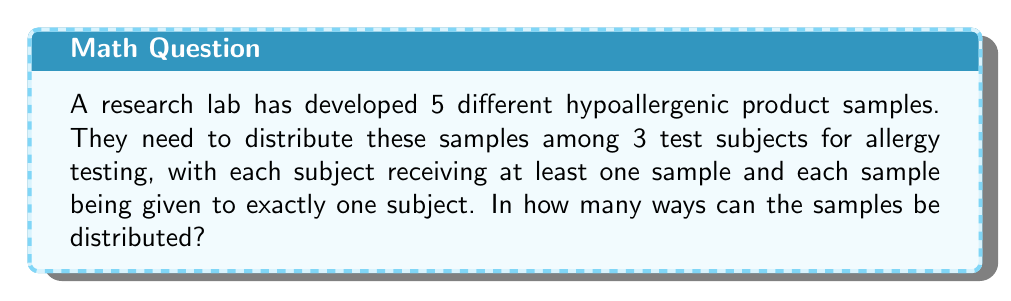Provide a solution to this math problem. Let's approach this step-by-step:

1) This is a partition problem, where we need to distribute 5 distinct objects (samples) into 3 non-empty subsets (test subjects).

2) This type of problem can be solved using Stirling numbers of the second kind, denoted as $\stirling{n}{k}$, where $n$ is the number of objects and $k$ is the number of subsets.

3) The formula for this scenario is:

   $$3! \cdot \stirling{5}{3}$$

   Where 3! accounts for the permutations of the 3 subjects.

4) To calculate $\stirling{5}{3}$, we can use the recursive formula:

   $$\stirling{n}{k} = k\stirling{n-1}{k} + \stirling{n-1}{k-1}$$

5) Let's calculate the necessary Stirling numbers:

   $$\stirling{3}{2} = 2\stirling{2}{2} + \stirling{2}{1} = 2(1) + 1 = 3$$
   $$\stirling{4}{2} = 2\stirling{3}{2} + \stirling{3}{1} = 2(3) + 1 = 7$$
   $$\stirling{4}{3} = 3\stirling{3}{3} + \stirling{3}{2} = 3(1) + 3 = 6$$
   $$\stirling{5}{3} = 3\stirling{4}{3} + \stirling{4}{2} = 3(6) + 7 = 25$$

6) Now we can plug this into our formula:

   $$3! \cdot \stirling{5}{3} = 6 \cdot 25 = 150$$

Therefore, there are 150 ways to distribute the samples.
Answer: 150 